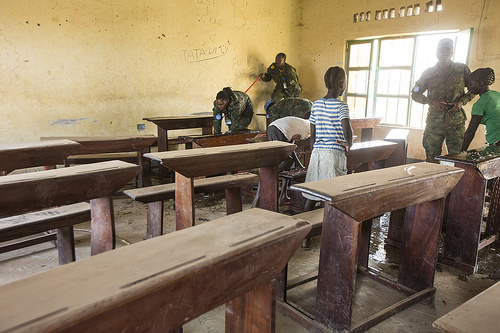<image>
Is there a table under the window? No. The table is not positioned under the window. The vertical relationship between these objects is different. Is the desk in front of the officer? Yes. The desk is positioned in front of the officer, appearing closer to the camera viewpoint. 